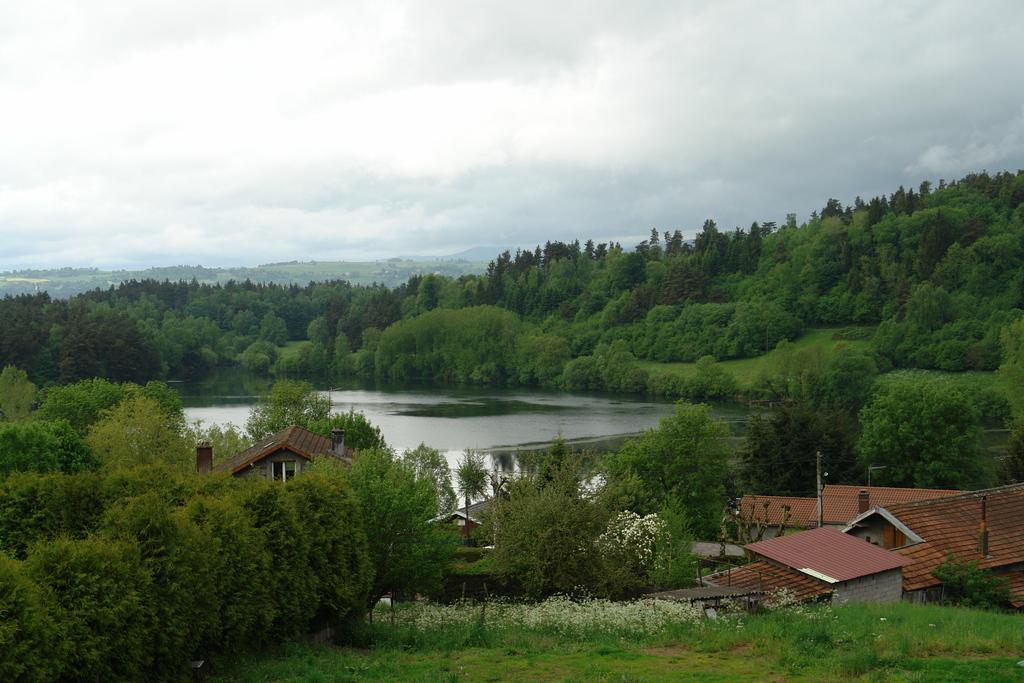Could you give a brief overview of what you see in this image? In this image there are trees, plants, houses, cloudy sky, grass and objects. 